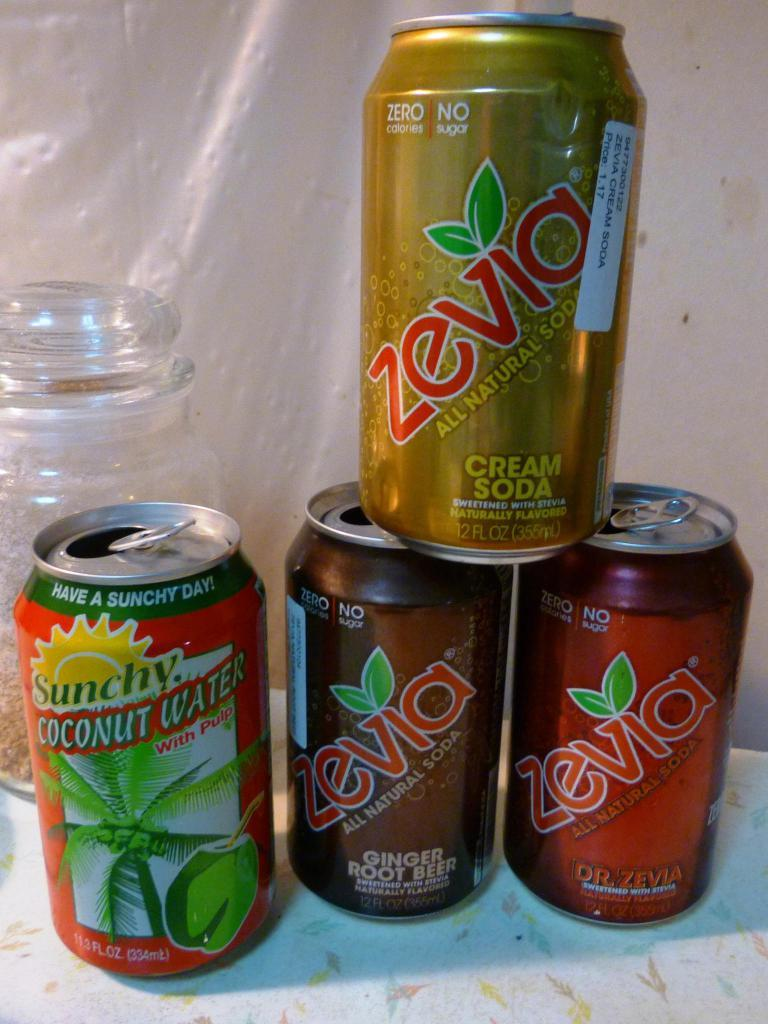<image>
Share a concise interpretation of the image provided. Three Zevia cans are stacked on a table next to a can of coconut water. 